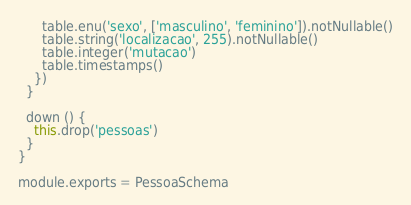<code> <loc_0><loc_0><loc_500><loc_500><_JavaScript_>      table.enu('sexo', ['masculino', 'feminino']).notNullable()
      table.string('localizacao', 255).notNullable()
      table.integer('mutacao')
      table.timestamps()
    })
  }

  down () {
    this.drop('pessoas')
  }
}

module.exports = PessoaSchema
</code> 